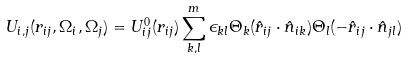<formula> <loc_0><loc_0><loc_500><loc_500>U _ { i , j } ( r _ { i j } , \Omega _ { i } , \Omega _ { j } ) = U ^ { 0 } _ { i j } ( r _ { i j } ) \sum _ { k , l } ^ { m } \epsilon _ { k l } \Theta _ { k } ( \hat { r } _ { i j } \cdot \hat { n } _ { i k } ) \Theta _ { l } ( - \hat { r } _ { i j } \cdot \hat { n } _ { j l } )</formula> 